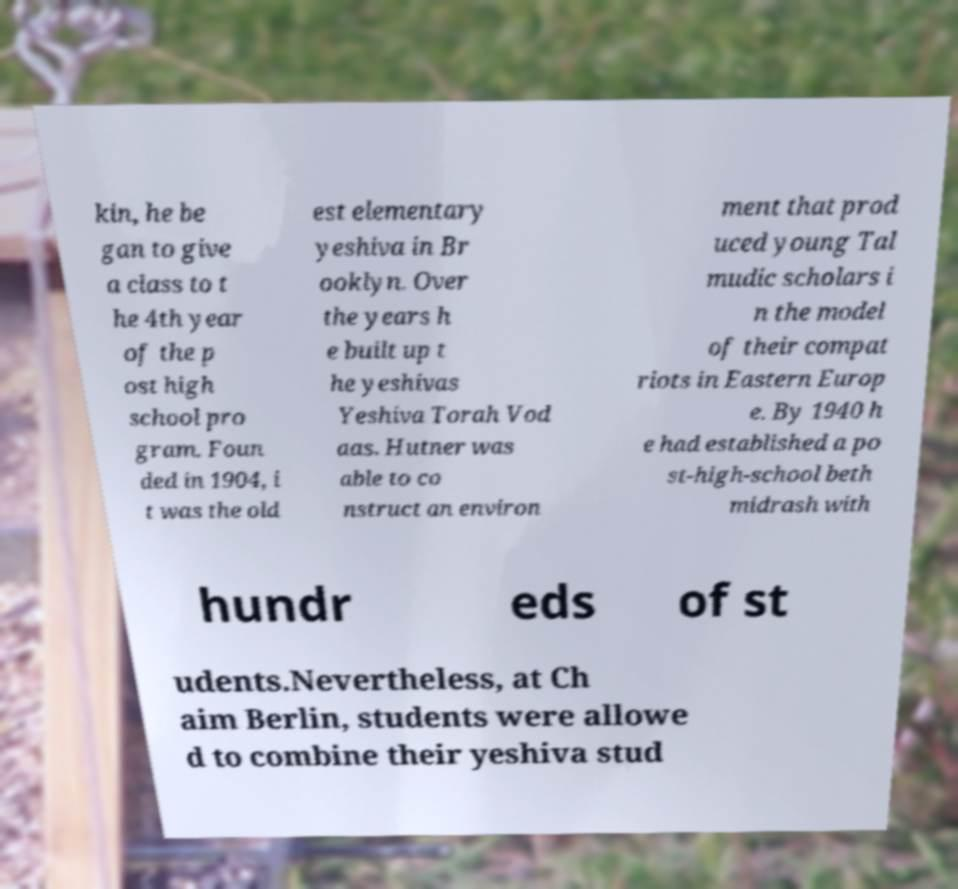For documentation purposes, I need the text within this image transcribed. Could you provide that? kin, he be gan to give a class to t he 4th year of the p ost high school pro gram. Foun ded in 1904, i t was the old est elementary yeshiva in Br ooklyn. Over the years h e built up t he yeshivas Yeshiva Torah Vod aas. Hutner was able to co nstruct an environ ment that prod uced young Tal mudic scholars i n the model of their compat riots in Eastern Europ e. By 1940 h e had established a po st-high-school beth midrash with hundr eds of st udents.Nevertheless, at Ch aim Berlin, students were allowe d to combine their yeshiva stud 